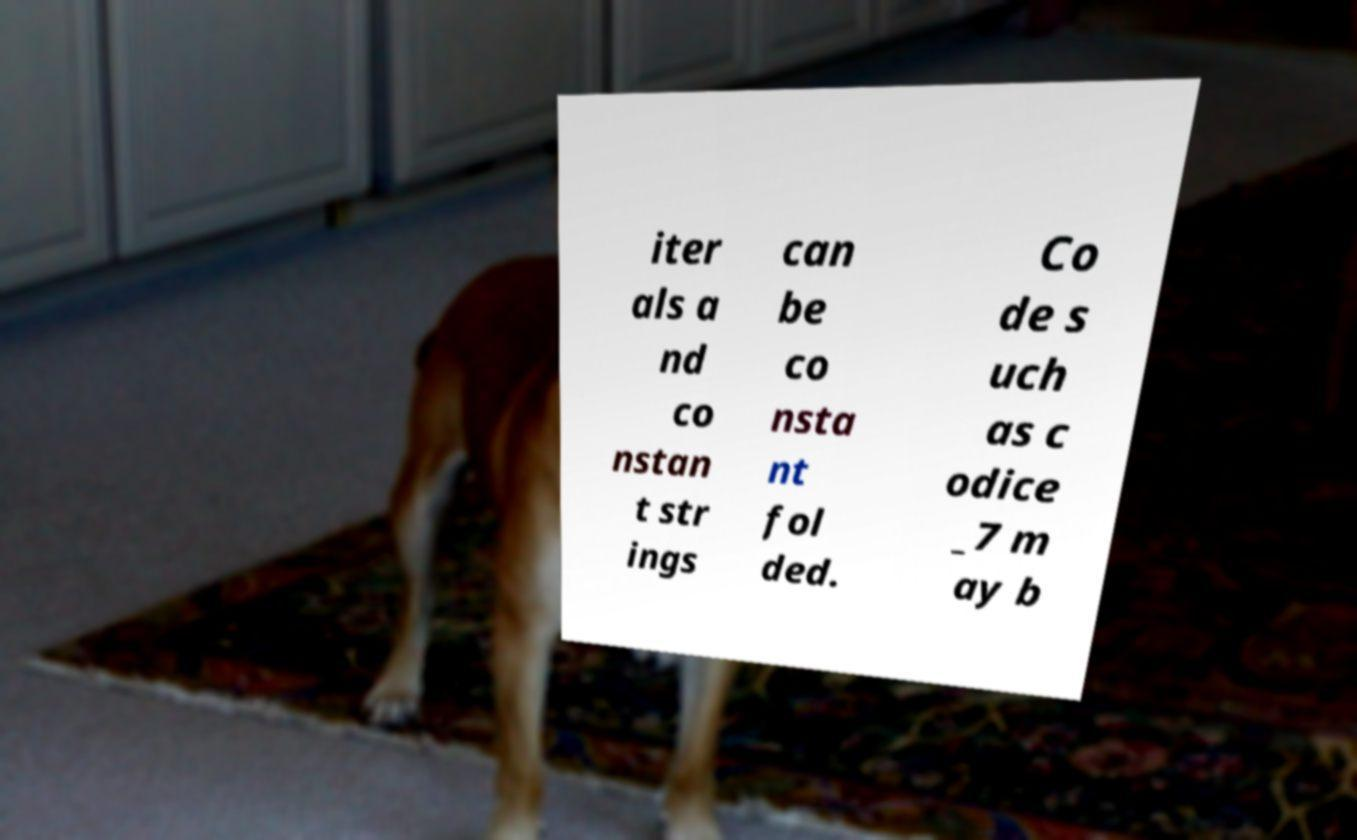Please read and relay the text visible in this image. What does it say? iter als a nd co nstan t str ings can be co nsta nt fol ded. Co de s uch as c odice _7 m ay b 